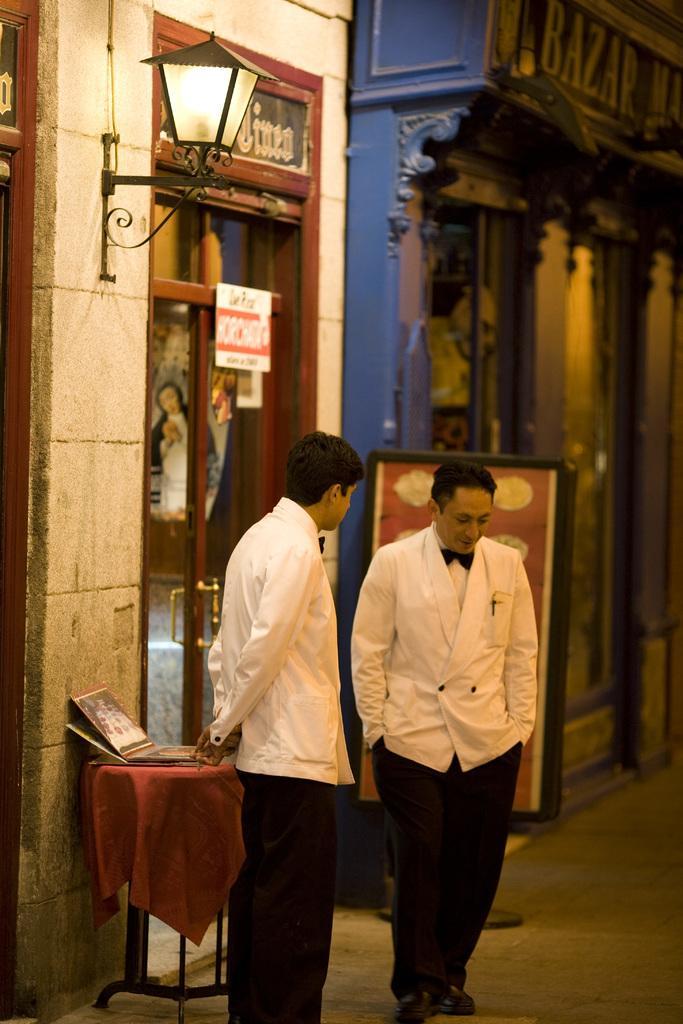Could you give a brief overview of what you see in this image? In this picture I can see in the middle two men are there, they are wearing trousers, coats. At the top there is a lamp, it looks like a store. 